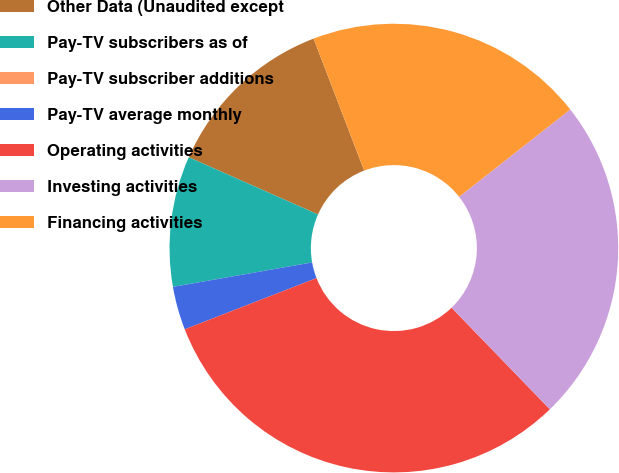<chart> <loc_0><loc_0><loc_500><loc_500><pie_chart><fcel>Other Data (Unaudited except<fcel>Pay-TV subscribers as of<fcel>Pay-TV subscriber additions<fcel>Pay-TV average monthly<fcel>Operating activities<fcel>Investing activities<fcel>Financing activities<nl><fcel>12.54%<fcel>9.4%<fcel>0.0%<fcel>3.13%<fcel>31.34%<fcel>23.36%<fcel>20.22%<nl></chart> 